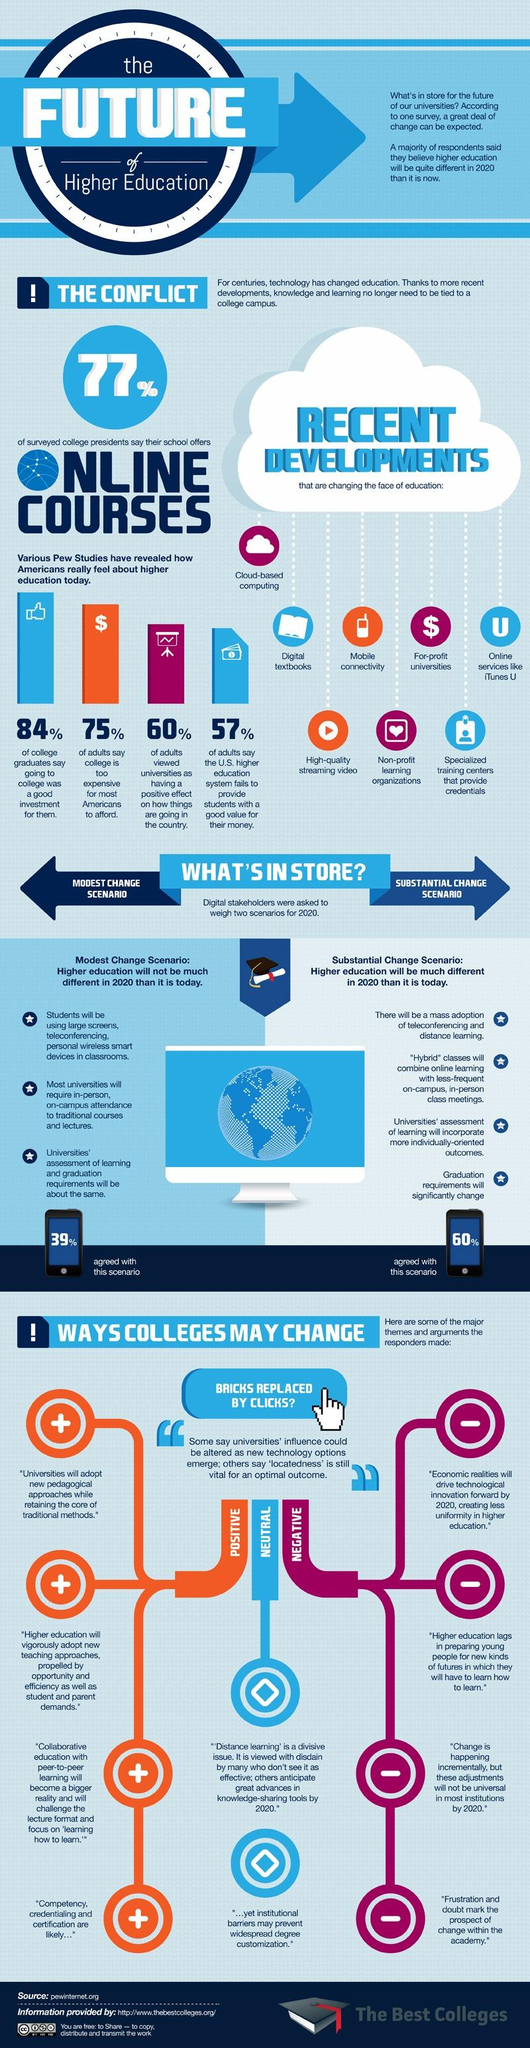List a handful of essential elements in this visual. According to a recent survey, 57% of adults believe that the U.S. higher education system fails to provide students with a good value for their money. A majority of college graduates in the United States, 84%, believe that attending college was a good investment for them. According to a recent survey, 75% of adults believe that college is too expensive for most Americans to afford. 